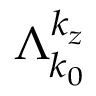Convert formula to latex. <formula><loc_0><loc_0><loc_500><loc_500>\Lambda _ { k _ { 0 } } ^ { k _ { z } }</formula> 